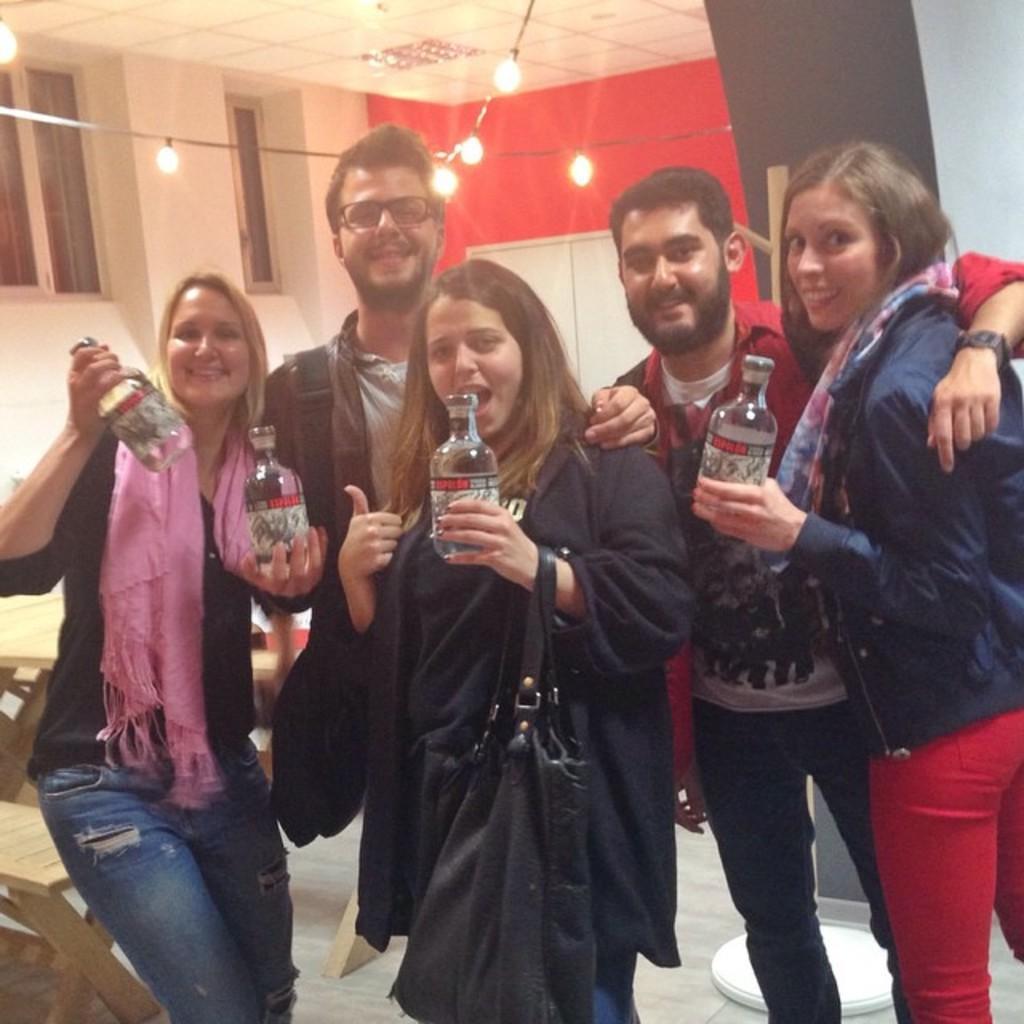Can you describe this image briefly? This image consists of 5 people. Three women and 2 men. Three women are holding some bottles. There are lights at the top. There are windows on the left side. There is a bench on the left side. 